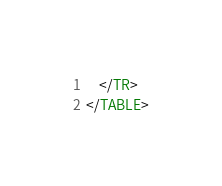<code> <loc_0><loc_0><loc_500><loc_500><_HTML_>	</TR>
</TABLE></code> 